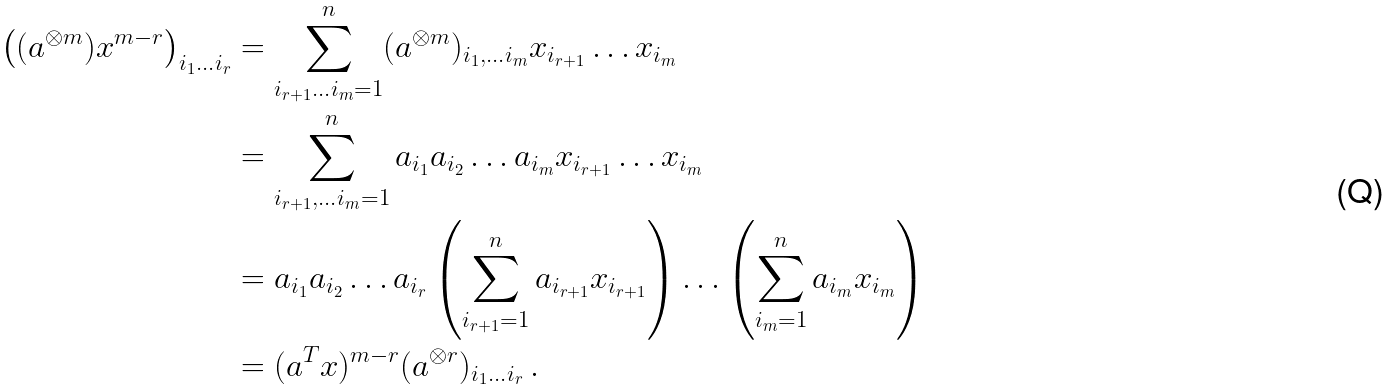Convert formula to latex. <formula><loc_0><loc_0><loc_500><loc_500>\left ( ( a ^ { \otimes m } ) x ^ { m - r } \right ) _ { i _ { 1 } \dots i _ { r } } & = \sum _ { i _ { r + 1 } \dots i _ { m } = 1 } ^ { n } ( a ^ { \otimes m } ) _ { i _ { 1 } , \dots i _ { m } } x _ { i _ { r + 1 } } \dots x _ { i _ { m } } \\ & = \sum _ { i _ { r + 1 } , \dots i _ { m } = 1 } ^ { n } a _ { i _ { 1 } } a _ { i _ { 2 } } \dots a _ { i _ { m } } x _ { i _ { r + 1 } } \dots x _ { i _ { m } } \\ & = a _ { i _ { 1 } } a _ { i _ { 2 } } \dots a _ { i _ { r } } \left ( \sum _ { i _ { r + 1 } = 1 } ^ { n } a _ { i _ { r + 1 } } x _ { i _ { r + 1 } } \right ) \dots \left ( \sum _ { i _ { m } = 1 } ^ { n } a _ { i _ { m } } x _ { i _ { m } } \right ) \\ & = ( a ^ { T } x ) ^ { m - r } ( a ^ { \otimes r } ) _ { i _ { 1 } \dots i _ { r } } \, .</formula> 